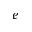<formula> <loc_0><loc_0><loc_500><loc_500>e</formula> 